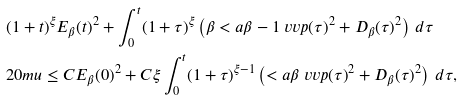<formula> <loc_0><loc_0><loc_500><loc_500>& ( 1 + t ) ^ { \xi } E _ { \beta } ( t ) ^ { 2 } + \int _ { 0 } ^ { t } ( 1 + \tau ) ^ { \xi } \left ( \beta < a { \beta - 1 } { \ v v p ( \tau ) } ^ { 2 } + D _ { \beta } ( \tau ) ^ { 2 } \right ) \, d \tau \\ & { 2 0 m u } \leq C E _ { \beta } ( 0 ) ^ { 2 } + C \xi \int _ { 0 } ^ { t } ( 1 + \tau ) ^ { \xi - 1 } \left ( < a { \beta } { \ v v p ( \tau ) } ^ { 2 } + D _ { \beta } ( \tau ) ^ { 2 } \right ) \, d \tau ,</formula> 